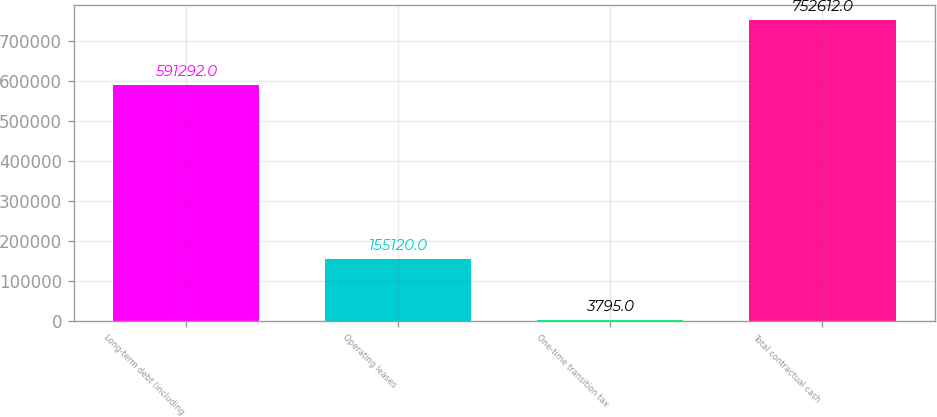Convert chart. <chart><loc_0><loc_0><loc_500><loc_500><bar_chart><fcel>Long-term debt (including<fcel>Operating leases<fcel>One-time transition tax<fcel>Total contractual cash<nl><fcel>591292<fcel>155120<fcel>3795<fcel>752612<nl></chart> 